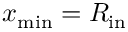Convert formula to latex. <formula><loc_0><loc_0><loc_500><loc_500>x _ { \min } = R _ { i n }</formula> 